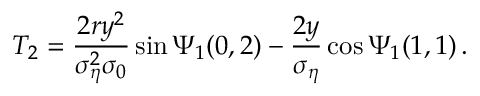Convert formula to latex. <formula><loc_0><loc_0><loc_500><loc_500>T _ { 2 } = \frac { 2 r y ^ { 2 } } { \sigma _ { \eta } ^ { 2 } \sigma _ { 0 } } \sin \Psi _ { 1 } ( 0 , 2 ) - \frac { 2 y } { \sigma _ { \eta } } \cos \Psi _ { 1 } ( 1 , 1 ) \, .</formula> 